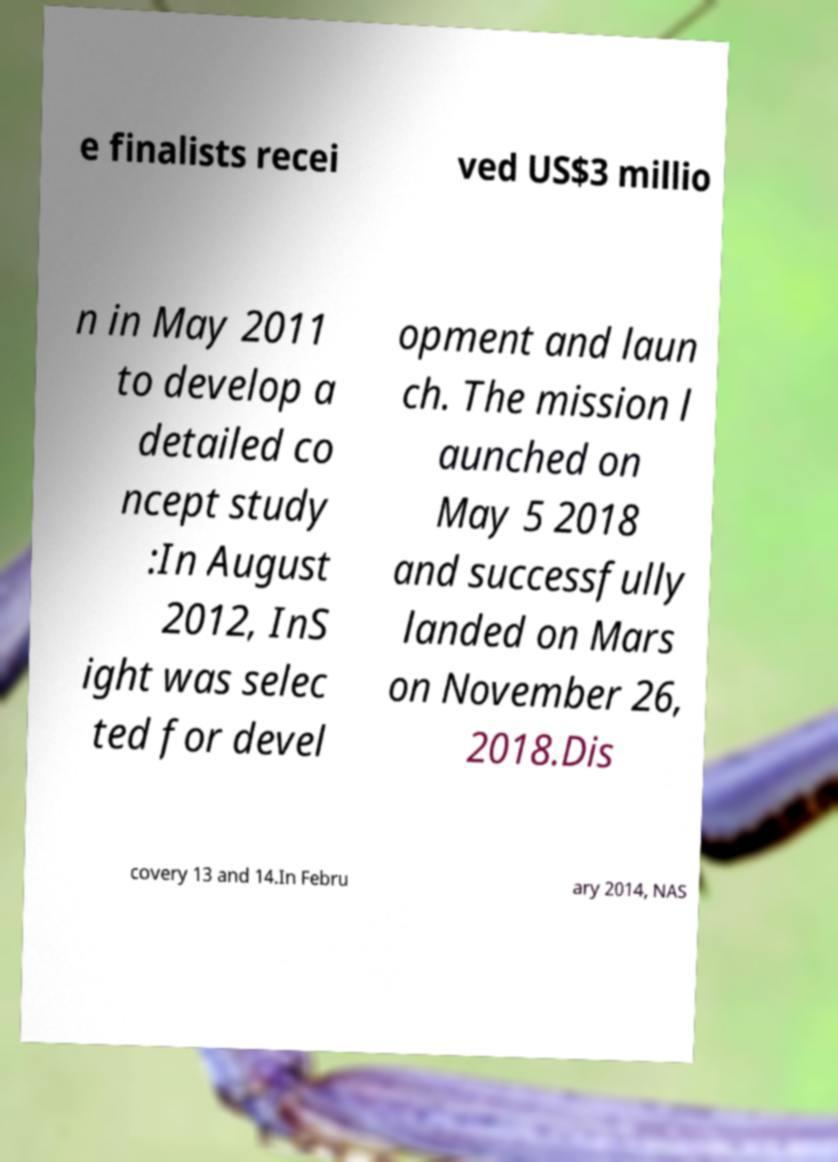There's text embedded in this image that I need extracted. Can you transcribe it verbatim? e finalists recei ved US$3 millio n in May 2011 to develop a detailed co ncept study :In August 2012, InS ight was selec ted for devel opment and laun ch. The mission l aunched on May 5 2018 and successfully landed on Mars on November 26, 2018.Dis covery 13 and 14.In Febru ary 2014, NAS 